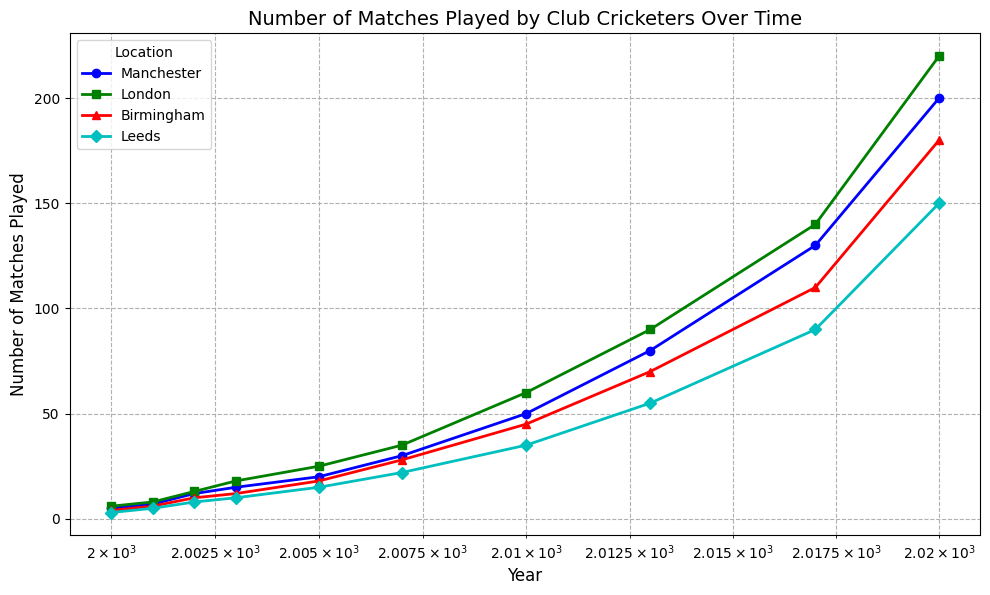Which location had the highest number of matches played in 2020? Look at the end of the time series (year 2020) for each location. Manchester has 200, London has 220, Birmingham has 180, and Leeds has 150. London has the highest number of matches played in 2020.
Answer: London Between which two years did Manchester experience the largest increase in matches played? Examine the data points for Manchester and calculate the differences in matches played between consecutive years. The largest increase is between 2017 (130 matches) and 2020 (200 matches), which is an increase of 70 matches.
Answer: 2017 and 2020 What is the difference in the number of matches played between Leeds and Birmingham in 2013? Locate the data points for Leeds in 2013 (55 matches) and Birmingham in 2013 (70 matches). Subtract the number of matches played in Leeds from the number of matches played in Birmingham: 70 - 55 = 15.
Answer: 15 Which location experienced the most consistent growth in the number of matches played over the years? Consistent growth can be observed by the smoothness and regular interval of the line on the log-scale plot. Manchester, London, Birmingham, and Leeds all show growth patterns, but London appears the smoothest and most consistent in growth without abrupt changes.
Answer: London What is the average number of matches played in Leeds from 2010 to 2020? Locate the data points for Leeds for the years 2010, 2013, 2017, and 2020. The number of matches are 35, 55, 90, and 150 respectively. Add these numbers and divide by the number of years: (35+55+90+150)/4 = 82.5.
Answer: 82.5 How did the number of matches played in Birmingham in 2005 compare to the number of matches played in Leeds in 2002? Locate the data points: Birmingham in 2005 (18 matches) and Leeds in 2002 (8 matches). Compare these two numbers to find that Birmingham had more matches played.
Answer: Birmingham had more How many years did it take for Manchester to reach 80 matches played from the year it had 30 matches played? Identify the years: Manchester had 30 matches in 2007 and 80 matches in 2013. Subtract the years: 2013 - 2007 = 6 years.
Answer: 6 years Among the four locations, which one had the least number of matches played in the year 2000? Compare the number of matches played in 2000 for all locations: Manchester (5), London (6), Birmingham (4), Leeds (3). Leeds had the least number of matches played in 2000.
Answer: Leeds What is the total number of matches played in Manchester and London combined for the year 2017? Find the number of matches played in 2017 for both Manchester (130 matches) and London (140 matches) and add them together: 130 + 140 = 270.
Answer: 270 